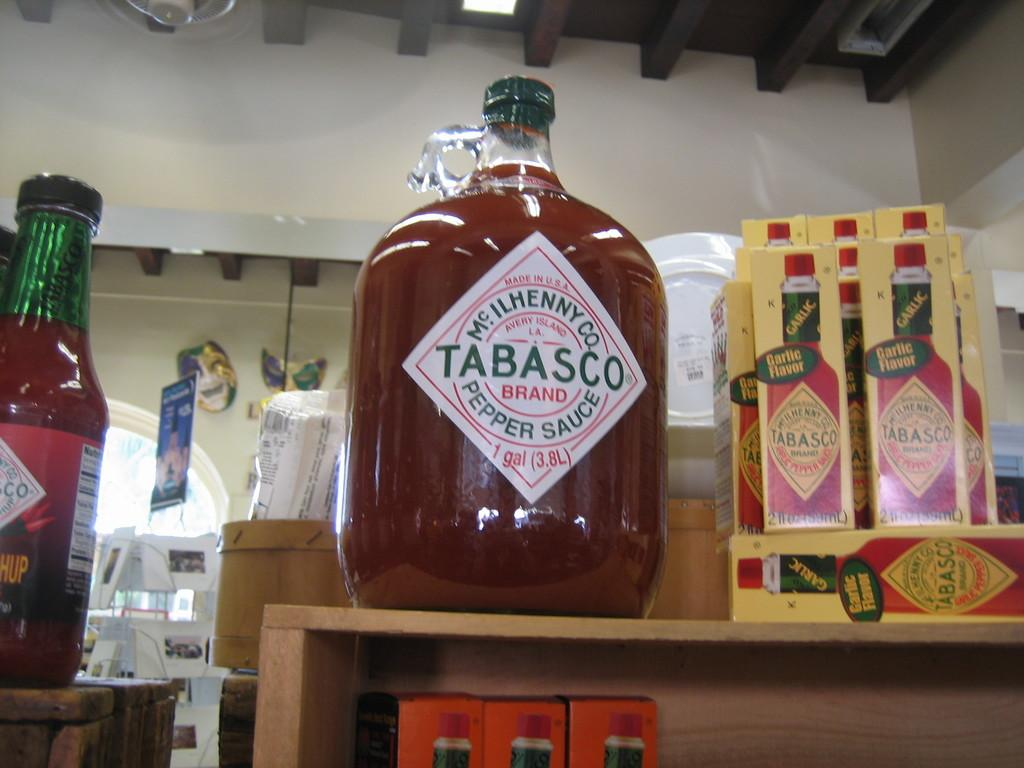<image>
Present a compact description of the photo's key features. Bottle of Tabasco pepper sauce next to some other bottles. 